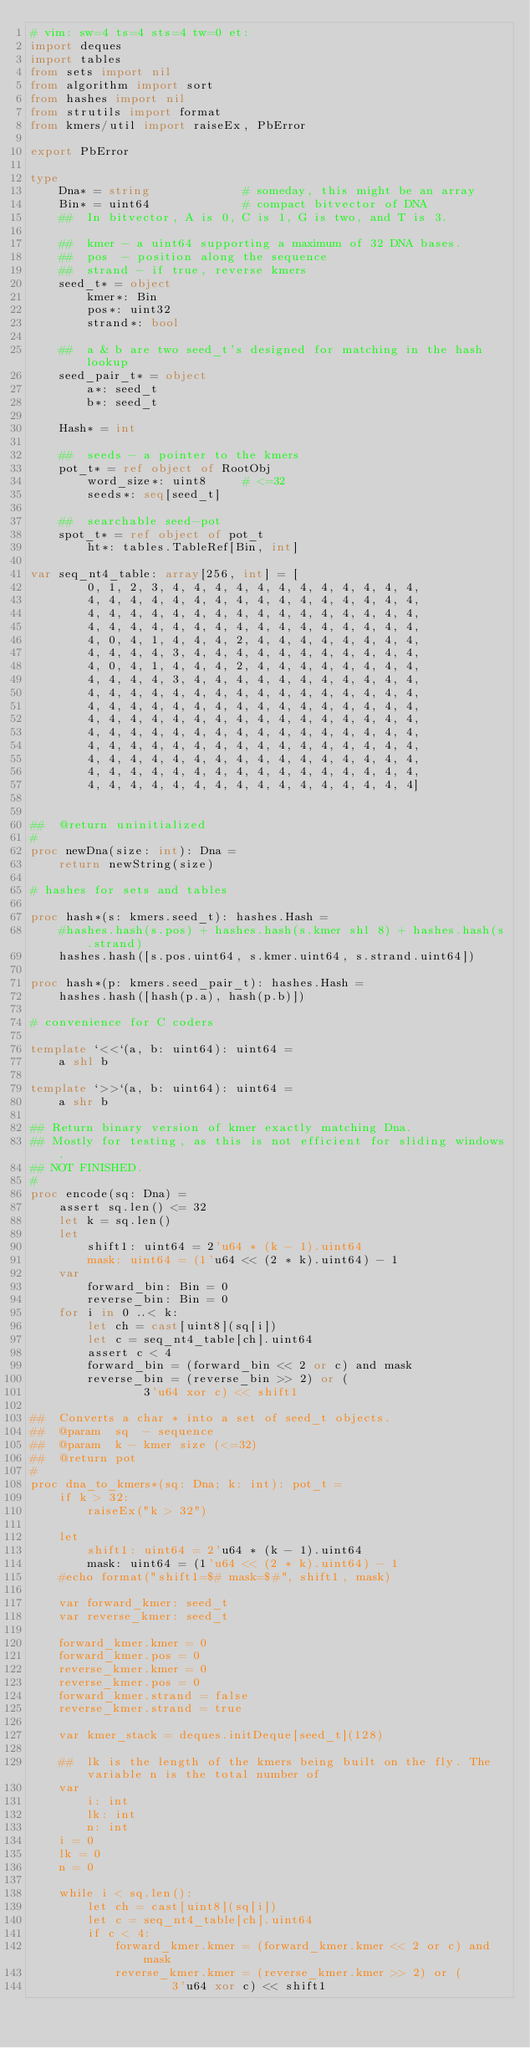<code> <loc_0><loc_0><loc_500><loc_500><_Nim_># vim: sw=4 ts=4 sts=4 tw=0 et:
import deques
import tables
from sets import nil
from algorithm import sort
from hashes import nil
from strutils import format
from kmers/util import raiseEx, PbError

export PbError

type
    Dna* = string             # someday, this might be an array
    Bin* = uint64             # compact bitvector of DNA
    ##  In bitvector, A is 0, C is 1, G is two, and T is 3.

    ##  kmer - a uint64 supporting a maximum of 32 DNA bases.
    ##  pos  - position along the sequence
    ##  strand - if true, reverse kmers
    seed_t* = object
        kmer*: Bin
        pos*: uint32
        strand*: bool

    ##  a & b are two seed_t's designed for matching in the hash lookup
    seed_pair_t* = object
        a*: seed_t
        b*: seed_t

    Hash* = int

    ##  seeds - a pointer to the kmers
    pot_t* = ref object of RootObj
        word_size*: uint8     # <=32
        seeds*: seq[seed_t]

    ##  searchable seed-pot
    spot_t* = ref object of pot_t
        ht*: tables.TableRef[Bin, int]

var seq_nt4_table: array[256, int] = [
        0, 1, 2, 3, 4, 4, 4, 4, 4, 4, 4, 4, 4, 4, 4, 4,
        4, 4, 4, 4, 4, 4, 4, 4, 4, 4, 4, 4, 4, 4, 4, 4,
        4, 4, 4, 4, 4, 4, 4, 4, 4, 4, 4, 4, 4, 4, 4, 4,
        4, 4, 4, 4, 4, 4, 4, 4, 4, 4, 4, 4, 4, 4, 4, 4,
        4, 0, 4, 1, 4, 4, 4, 2, 4, 4, 4, 4, 4, 4, 4, 4,
        4, 4, 4, 4, 3, 4, 4, 4, 4, 4, 4, 4, 4, 4, 4, 4,
        4, 0, 4, 1, 4, 4, 4, 2, 4, 4, 4, 4, 4, 4, 4, 4,
        4, 4, 4, 4, 3, 4, 4, 4, 4, 4, 4, 4, 4, 4, 4, 4,
        4, 4, 4, 4, 4, 4, 4, 4, 4, 4, 4, 4, 4, 4, 4, 4,
        4, 4, 4, 4, 4, 4, 4, 4, 4, 4, 4, 4, 4, 4, 4, 4,
        4, 4, 4, 4, 4, 4, 4, 4, 4, 4, 4, 4, 4, 4, 4, 4,
        4, 4, 4, 4, 4, 4, 4, 4, 4, 4, 4, 4, 4, 4, 4, 4,
        4, 4, 4, 4, 4, 4, 4, 4, 4, 4, 4, 4, 4, 4, 4, 4,
        4, 4, 4, 4, 4, 4, 4, 4, 4, 4, 4, 4, 4, 4, 4, 4,
        4, 4, 4, 4, 4, 4, 4, 4, 4, 4, 4, 4, 4, 4, 4, 4,
        4, 4, 4, 4, 4, 4, 4, 4, 4, 4, 4, 4, 4, 4, 4, 4]


##  @return uninitialized
#
proc newDna(size: int): Dna =
    return newString(size)

# hashes for sets and tables

proc hash*(s: kmers.seed_t): hashes.Hash =
    #hashes.hash(s.pos) + hashes.hash(s.kmer shl 8) + hashes.hash(s.strand)
    hashes.hash([s.pos.uint64, s.kmer.uint64, s.strand.uint64])

proc hash*(p: kmers.seed_pair_t): hashes.Hash =
    hashes.hash([hash(p.a), hash(p.b)])

# convenience for C coders

template `<<`(a, b: uint64): uint64 =
    a shl b

template `>>`(a, b: uint64): uint64 =
    a shr b

## Return binary version of kmer exactly matching Dna.
## Mostly for testing, as this is not efficient for sliding windows.
## NOT FINISHED.
#
proc encode(sq: Dna) =
    assert sq.len() <= 32
    let k = sq.len()
    let
        shift1: uint64 = 2'u64 * (k - 1).uint64
        mask: uint64 = (1'u64 << (2 * k).uint64) - 1
    var
        forward_bin: Bin = 0
        reverse_bin: Bin = 0
    for i in 0 ..< k:
        let ch = cast[uint8](sq[i])
        let c = seq_nt4_table[ch].uint64
        assert c < 4
        forward_bin = (forward_bin << 2 or c) and mask
        reverse_bin = (reverse_bin >> 2) or (
                3'u64 xor c) << shift1

##  Converts a char * into a set of seed_t objects.
##  @param  sq  - sequence
##  @param  k - kmer size (<=32)
##  @return pot
#
proc dna_to_kmers*(sq: Dna; k: int): pot_t =
    if k > 32:
        raiseEx("k > 32")

    let
        shift1: uint64 = 2'u64 * (k - 1).uint64
        mask: uint64 = (1'u64 << (2 * k).uint64) - 1
    #echo format("shift1=$# mask=$#", shift1, mask)

    var forward_kmer: seed_t
    var reverse_kmer: seed_t

    forward_kmer.kmer = 0
    forward_kmer.pos = 0
    reverse_kmer.kmer = 0
    reverse_kmer.pos = 0
    forward_kmer.strand = false
    reverse_kmer.strand = true

    var kmer_stack = deques.initDeque[seed_t](128)

    ##  lk is the length of the kmers being built on the fly. The variable n is the total number of
    var
        i: int
        lk: int
        n: int
    i = 0
    lk = 0
    n = 0

    while i < sq.len():
        let ch = cast[uint8](sq[i])
        let c = seq_nt4_table[ch].uint64
        if c < 4:
            forward_kmer.kmer = (forward_kmer.kmer << 2 or c) and mask
            reverse_kmer.kmer = (reverse_kmer.kmer >> 2) or (
                    3'u64 xor c) << shift1</code> 